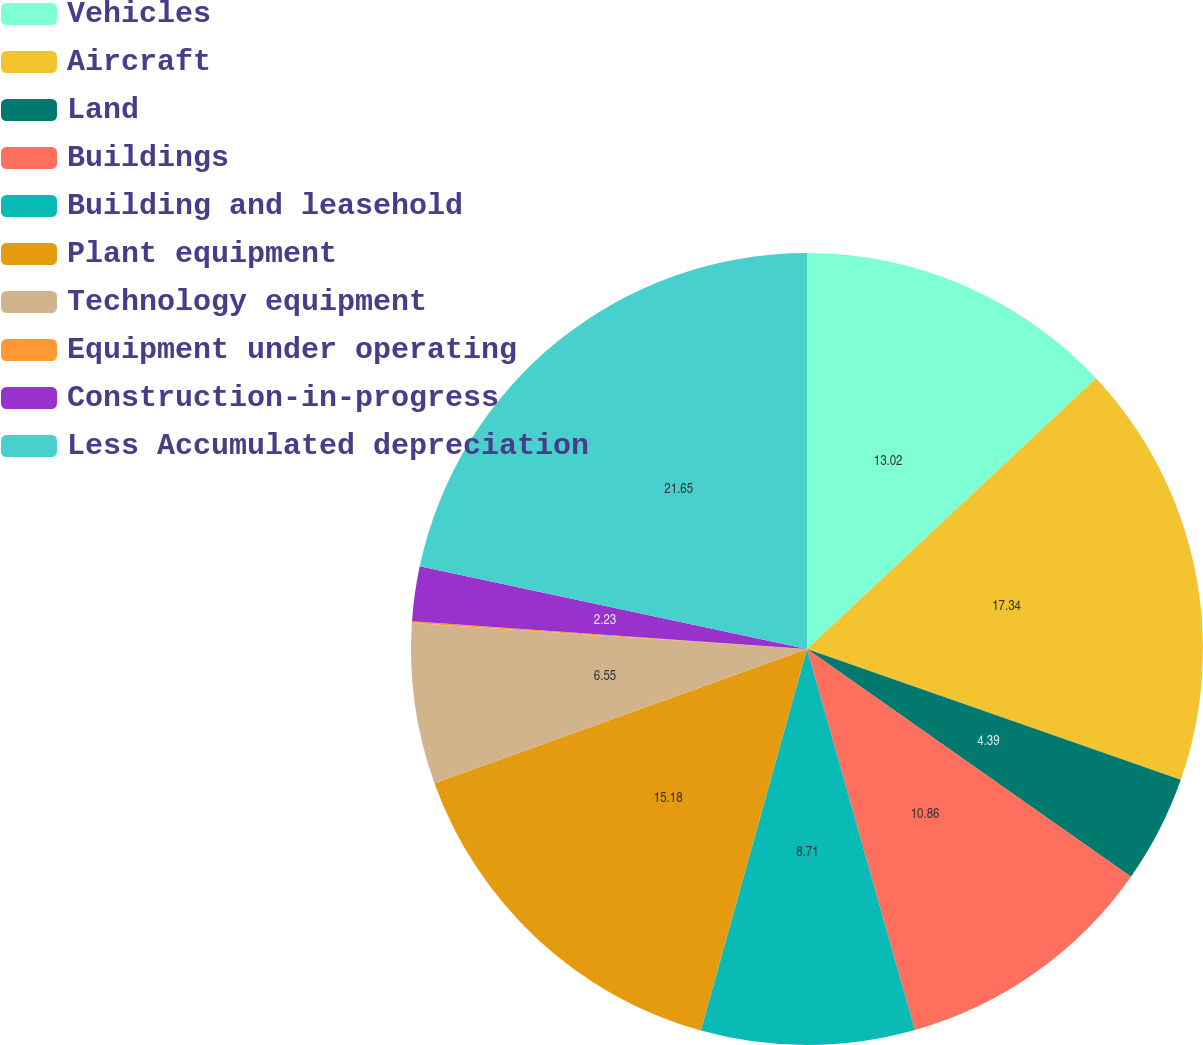<chart> <loc_0><loc_0><loc_500><loc_500><pie_chart><fcel>Vehicles<fcel>Aircraft<fcel>Land<fcel>Buildings<fcel>Building and leasehold<fcel>Plant equipment<fcel>Technology equipment<fcel>Equipment under operating<fcel>Construction-in-progress<fcel>Less Accumulated depreciation<nl><fcel>13.02%<fcel>17.34%<fcel>4.39%<fcel>10.86%<fcel>8.71%<fcel>15.18%<fcel>6.55%<fcel>0.07%<fcel>2.23%<fcel>21.65%<nl></chart> 